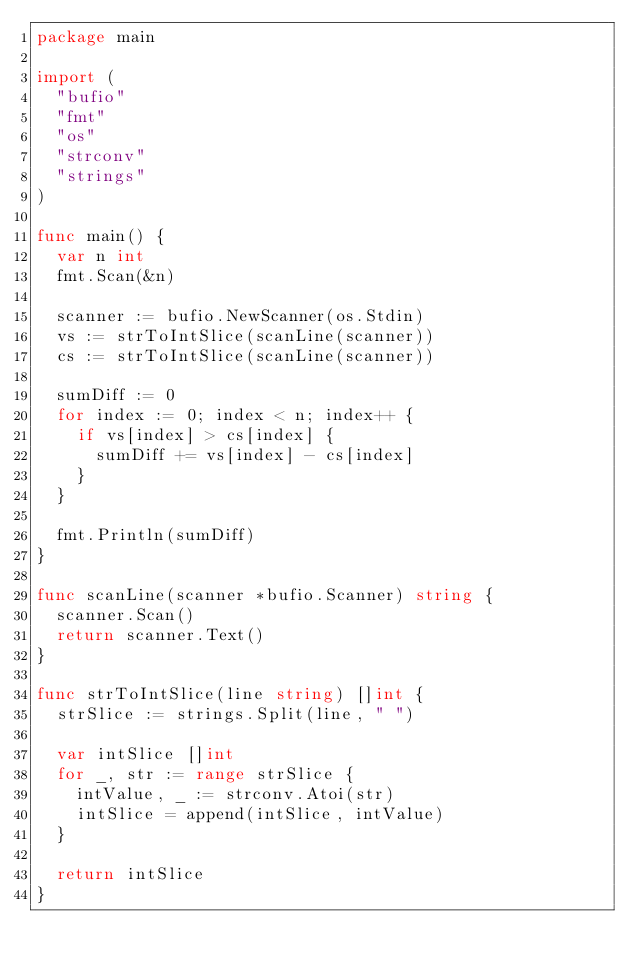Convert code to text. <code><loc_0><loc_0><loc_500><loc_500><_Go_>package main

import (
	"bufio"
	"fmt"
	"os"
	"strconv"
	"strings"
)

func main() {
	var n int
	fmt.Scan(&n)

	scanner := bufio.NewScanner(os.Stdin)
	vs := strToIntSlice(scanLine(scanner))
	cs := strToIntSlice(scanLine(scanner))

	sumDiff := 0
	for index := 0; index < n; index++ {
		if vs[index] > cs[index] {
			sumDiff += vs[index] - cs[index]
		}
	}

	fmt.Println(sumDiff)
}

func scanLine(scanner *bufio.Scanner) string {
	scanner.Scan()
	return scanner.Text()
}

func strToIntSlice(line string) []int {
	strSlice := strings.Split(line, " ")

	var intSlice []int
	for _, str := range strSlice {
		intValue, _ := strconv.Atoi(str)
		intSlice = append(intSlice, intValue)
	}

	return intSlice
}</code> 